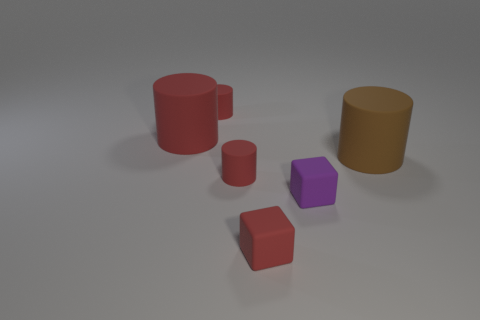Is there a small purple thing that has the same shape as the big red object?
Provide a succinct answer. No. The object that is right of the small red cube and behind the small purple cube has what shape?
Your answer should be very brief. Cylinder. Is the red block made of the same material as the big cylinder that is to the right of the purple matte object?
Offer a very short reply. Yes. Are there any red rubber blocks to the left of the big red rubber cylinder?
Keep it short and to the point. No. How many things are brown rubber cylinders or small rubber things that are in front of the big brown object?
Offer a very short reply. 4. The small rubber cylinder that is in front of the small red rubber object behind the large red rubber cylinder is what color?
Offer a terse response. Red. How many other things are the same material as the red block?
Make the answer very short. 5. How many matte things are small red things or tiny red blocks?
Make the answer very short. 3. What is the color of the other large object that is the same shape as the big red thing?
Your response must be concise. Brown. How many objects are either small red rubber objects or rubber cylinders?
Make the answer very short. 5. 